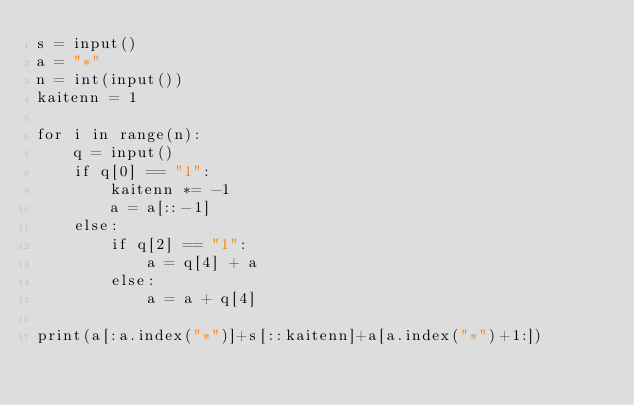<code> <loc_0><loc_0><loc_500><loc_500><_Python_>s = input()
a = "*"
n = int(input())
kaitenn = 1

for i in range(n):
    q = input()
    if q[0] == "1":
        kaitenn *= -1
        a = a[::-1]
    else:
        if q[2] == "1":
            a = q[4] + a
        else:
            a = a + q[4]
            
print(a[:a.index("*")]+s[::kaitenn]+a[a.index("*")+1:])</code> 